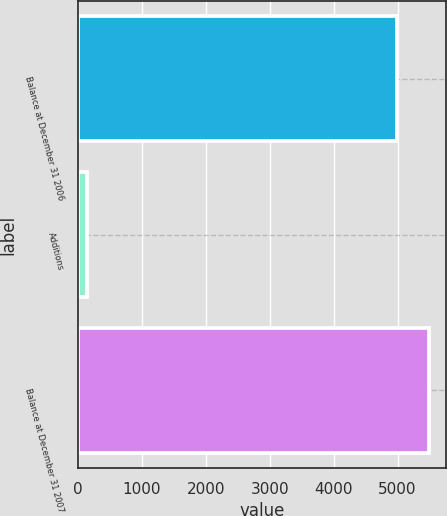Convert chart to OTSL. <chart><loc_0><loc_0><loc_500><loc_500><bar_chart><fcel>Balance at December 31 2006<fcel>Additions<fcel>Balance at December 31 2007<nl><fcel>4989<fcel>146<fcel>5488.6<nl></chart> 